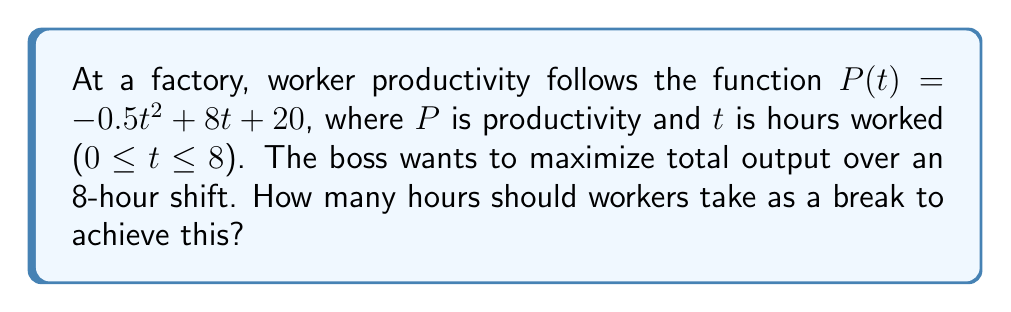Solve this math problem. Let's approach this step-by-step:

1) The total output over the shift is given by the integral of the productivity function:

   $$O = \int_0^{8-b} P(t) dt$$

   where $b$ is the break time and $(8-b)$ is the actual working time.

2) Expanding this integral:

   $$O = \int_0^{8-b} (-0.5t^2 + 8t + 20) dt$$

3) Solving the integral:

   $$O = [-\frac{1}{6}t^3 + 4t^2 + 20t]_0^{8-b}$$

   $$O = [-\frac{1}{6}(8-b)^3 + 4(8-b)^2 + 20(8-b)] - [0]$$

4) To find the maximum output, we need to differentiate $O$ with respect to $b$ and set it to zero:

   $$\frac{dO}{db} = \frac{1}{2}(8-b)^2 - 8(8-b) + 20 = 0$$

5) Simplifying:

   $$\frac{1}{2}(64-16b+b^2) - 64 + 8b + 20 = 0$$
   $$32 - 8b + \frac{1}{2}b^2 - 64 + 8b + 20 = 0$$
   $$\frac{1}{2}b^2 - 12 = 0$$
   $$b^2 = 24$$
   $$b = \sqrt{24} = 2\sqrt{6}$$

6) The second derivative is positive, confirming this is a maximum.
Answer: $2\sqrt{6}$ hours (approximately 4.9 hours) 